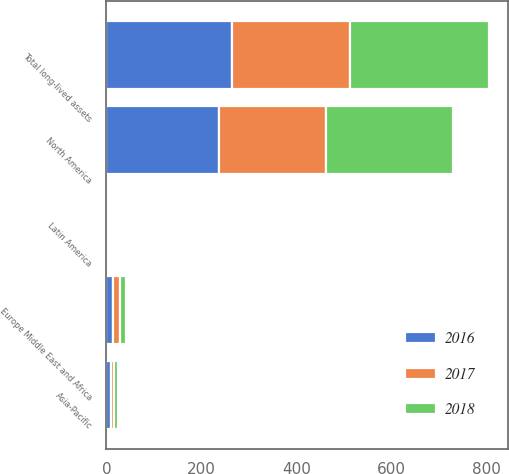Convert chart. <chart><loc_0><loc_0><loc_500><loc_500><stacked_bar_chart><ecel><fcel>North America<fcel>Europe Middle East and Africa<fcel>Asia-Pacific<fcel>Latin America<fcel>Total long-lived assets<nl><fcel>2017<fcel>225<fcel>14<fcel>7<fcel>3<fcel>249<nl><fcel>2016<fcel>238<fcel>14<fcel>9<fcel>3<fcel>264<nl><fcel>2018<fcel>267<fcel>13<fcel>9<fcel>3<fcel>292<nl></chart> 